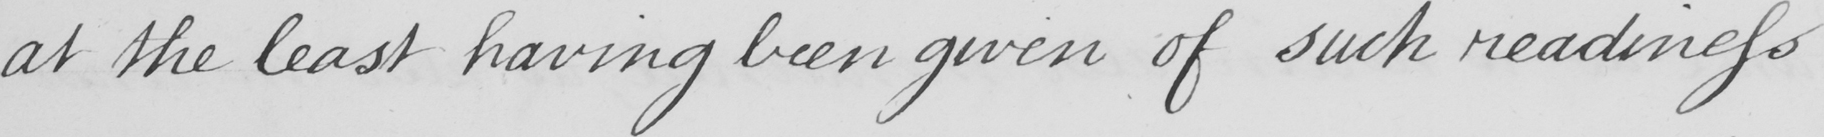Can you tell me what this handwritten text says? at the least having been given of such readiness 